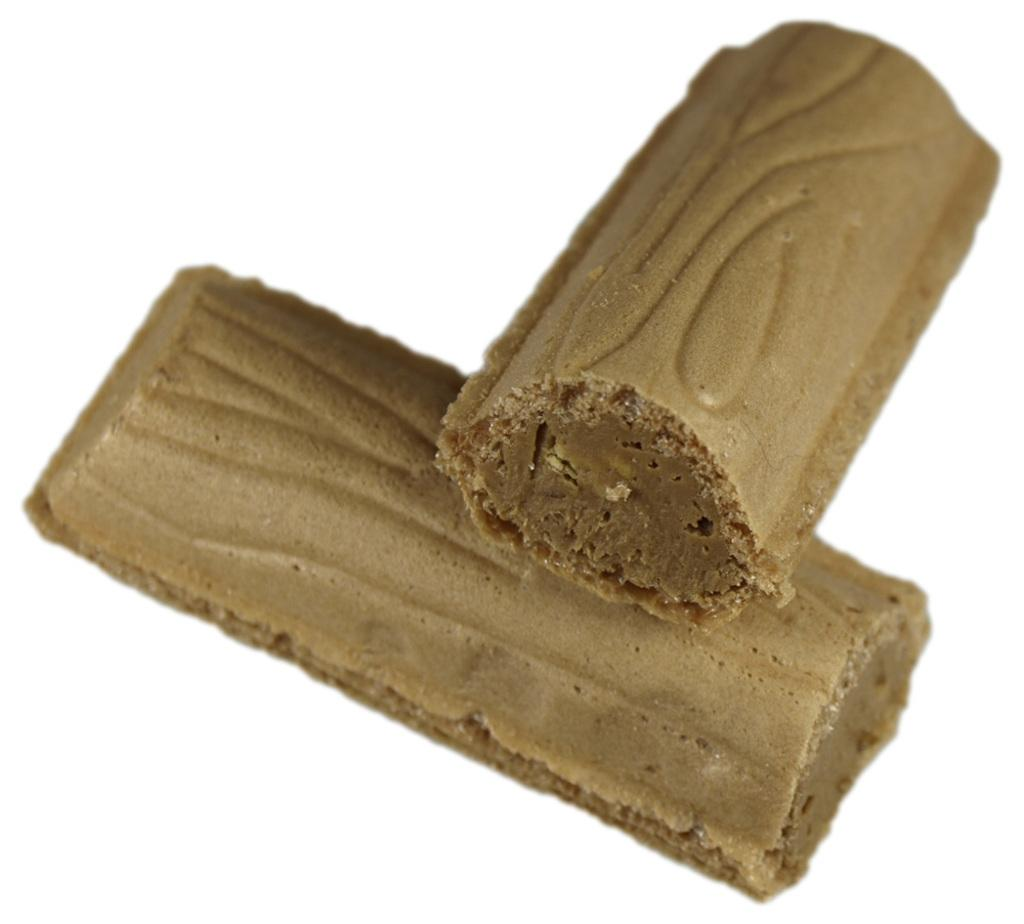What type of food can be seen in the image? There are two pieces of chocolate in the image. What type of land can be seen in the image? There is no land visible in the image; it only features two pieces of chocolate. How many eggs are present in the image? There are no eggs present in the image; it only features two pieces of chocolate. 